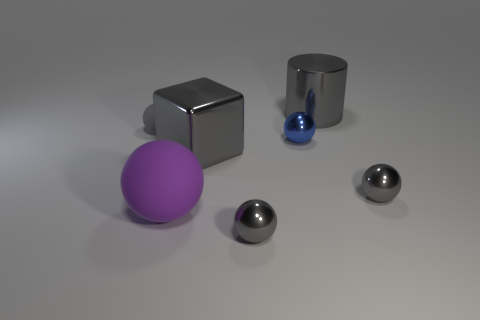What material is the big cube that is the same color as the metallic cylinder?
Offer a very short reply. Metal. What number of other objects are there of the same color as the big metal block?
Provide a short and direct response. 4. There is a big metallic thing in front of the tiny gray rubber ball; is its shape the same as the big gray metallic object behind the tiny gray rubber thing?
Provide a short and direct response. No. How many things are rubber spheres right of the small gray matte object or spheres that are in front of the purple matte ball?
Provide a short and direct response. 2. How many other objects are the same material as the large purple thing?
Make the answer very short. 1. Is the material of the tiny thing that is in front of the big rubber thing the same as the gray cube?
Your answer should be compact. Yes. Is the number of large gray cylinders in front of the blue thing greater than the number of large cylinders to the left of the purple ball?
Offer a very short reply. No. What number of objects are tiny gray metal things that are left of the metal cylinder or small brown metallic cubes?
Ensure brevity in your answer.  1. There is a big object that is the same material as the cylinder; what shape is it?
Your answer should be very brief. Cube. Is there anything else that has the same shape as the blue thing?
Keep it short and to the point. Yes. 